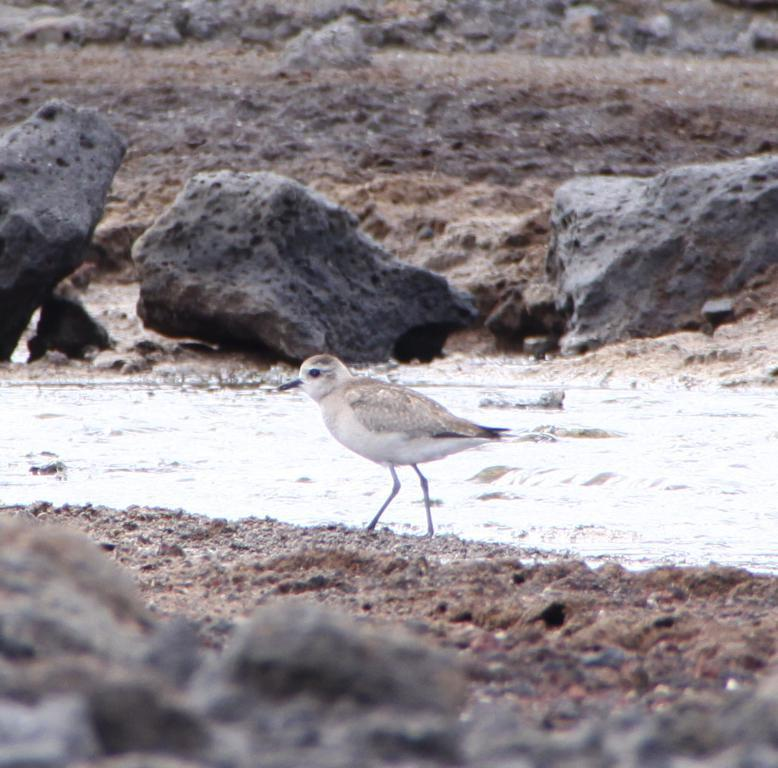What is the primary element present in the image? There is water in the image. What type of animal can be seen in the image? There is a bird in the image. What objects are present at the top and bottom of the image? Stones are visible at the top and bottom of the image. What is visible beneath the water and stones? The ground is visible in the image. Where is the mother bear and her cubs in the image? There is no mother bear or her cubs present in the image. What type of station is visible in the image? There is no station present in the image. 